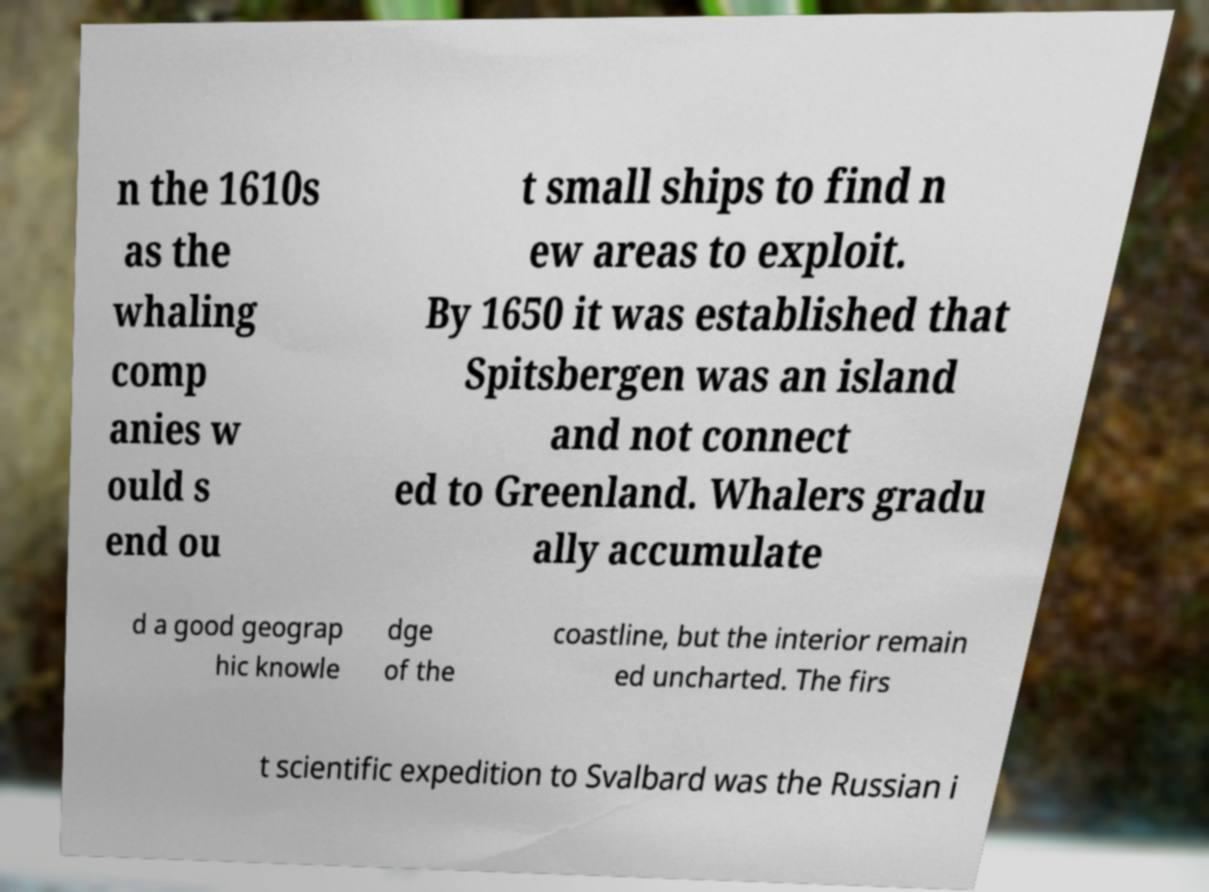Could you extract and type out the text from this image? n the 1610s as the whaling comp anies w ould s end ou t small ships to find n ew areas to exploit. By 1650 it was established that Spitsbergen was an island and not connect ed to Greenland. Whalers gradu ally accumulate d a good geograp hic knowle dge of the coastline, but the interior remain ed uncharted. The firs t scientific expedition to Svalbard was the Russian i 